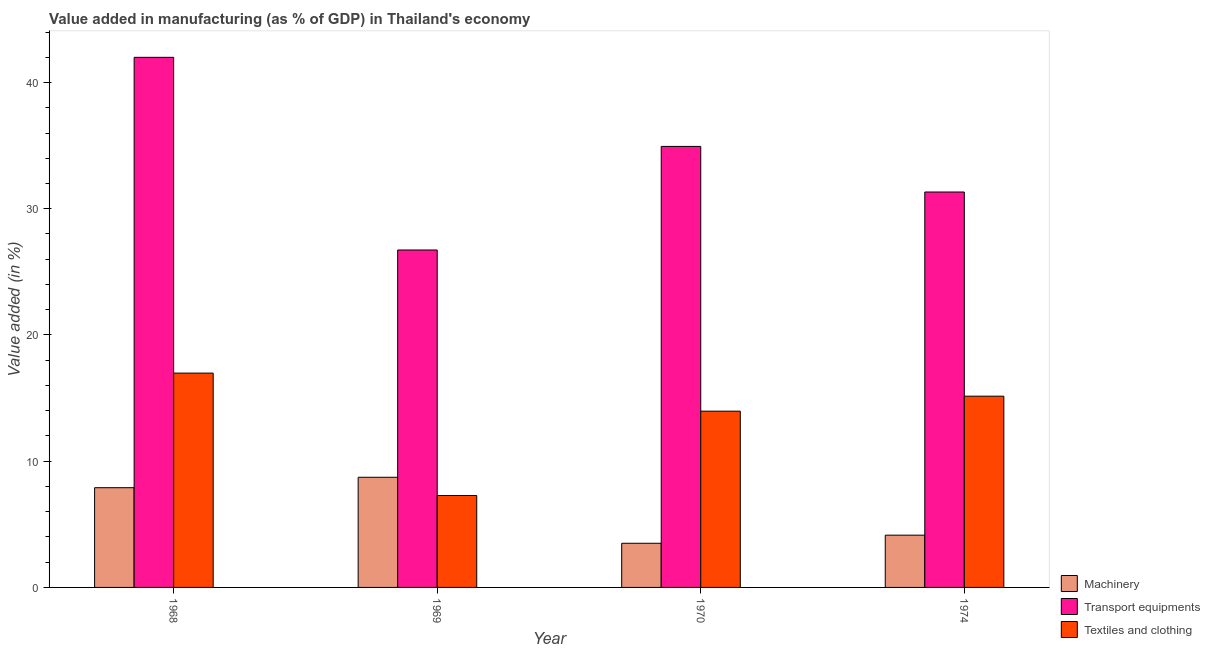How many different coloured bars are there?
Give a very brief answer. 3. Are the number of bars on each tick of the X-axis equal?
Keep it short and to the point. Yes. How many bars are there on the 3rd tick from the right?
Your answer should be compact. 3. What is the label of the 3rd group of bars from the left?
Offer a very short reply. 1970. In how many cases, is the number of bars for a given year not equal to the number of legend labels?
Make the answer very short. 0. What is the value added in manufacturing transport equipments in 1969?
Offer a terse response. 26.73. Across all years, what is the maximum value added in manufacturing transport equipments?
Your answer should be very brief. 41.99. Across all years, what is the minimum value added in manufacturing transport equipments?
Ensure brevity in your answer.  26.73. In which year was the value added in manufacturing transport equipments maximum?
Your response must be concise. 1968. In which year was the value added in manufacturing textile and clothing minimum?
Offer a terse response. 1969. What is the total value added in manufacturing textile and clothing in the graph?
Provide a succinct answer. 53.38. What is the difference between the value added in manufacturing machinery in 1969 and that in 1974?
Provide a short and direct response. 4.59. What is the difference between the value added in manufacturing machinery in 1969 and the value added in manufacturing textile and clothing in 1968?
Provide a succinct answer. 0.83. What is the average value added in manufacturing machinery per year?
Your answer should be compact. 6.07. In how many years, is the value added in manufacturing transport equipments greater than 36 %?
Offer a very short reply. 1. What is the ratio of the value added in manufacturing textile and clothing in 1968 to that in 1970?
Give a very brief answer. 1.22. Is the difference between the value added in manufacturing transport equipments in 1968 and 1970 greater than the difference between the value added in manufacturing textile and clothing in 1968 and 1970?
Keep it short and to the point. No. What is the difference between the highest and the second highest value added in manufacturing transport equipments?
Provide a succinct answer. 7.06. What is the difference between the highest and the lowest value added in manufacturing textile and clothing?
Ensure brevity in your answer.  9.7. What does the 3rd bar from the left in 1969 represents?
Provide a short and direct response. Textiles and clothing. What does the 2nd bar from the right in 1968 represents?
Your answer should be very brief. Transport equipments. Is it the case that in every year, the sum of the value added in manufacturing machinery and value added in manufacturing transport equipments is greater than the value added in manufacturing textile and clothing?
Your answer should be compact. Yes. How many bars are there?
Ensure brevity in your answer.  12. Does the graph contain grids?
Your answer should be very brief. No. Where does the legend appear in the graph?
Your answer should be very brief. Bottom right. What is the title of the graph?
Provide a short and direct response. Value added in manufacturing (as % of GDP) in Thailand's economy. What is the label or title of the Y-axis?
Provide a succinct answer. Value added (in %). What is the Value added (in %) in Machinery in 1968?
Offer a very short reply. 7.9. What is the Value added (in %) in Transport equipments in 1968?
Give a very brief answer. 41.99. What is the Value added (in %) of Textiles and clothing in 1968?
Ensure brevity in your answer.  16.98. What is the Value added (in %) in Machinery in 1969?
Offer a very short reply. 8.73. What is the Value added (in %) in Transport equipments in 1969?
Make the answer very short. 26.73. What is the Value added (in %) of Textiles and clothing in 1969?
Give a very brief answer. 7.28. What is the Value added (in %) of Machinery in 1970?
Ensure brevity in your answer.  3.5. What is the Value added (in %) in Transport equipments in 1970?
Keep it short and to the point. 34.94. What is the Value added (in %) of Textiles and clothing in 1970?
Offer a terse response. 13.96. What is the Value added (in %) of Machinery in 1974?
Offer a very short reply. 4.14. What is the Value added (in %) of Transport equipments in 1974?
Your answer should be very brief. 31.33. What is the Value added (in %) of Textiles and clothing in 1974?
Your answer should be very brief. 15.15. Across all years, what is the maximum Value added (in %) of Machinery?
Provide a short and direct response. 8.73. Across all years, what is the maximum Value added (in %) of Transport equipments?
Your answer should be compact. 41.99. Across all years, what is the maximum Value added (in %) of Textiles and clothing?
Give a very brief answer. 16.98. Across all years, what is the minimum Value added (in %) in Machinery?
Offer a terse response. 3.5. Across all years, what is the minimum Value added (in %) of Transport equipments?
Your answer should be very brief. 26.73. Across all years, what is the minimum Value added (in %) in Textiles and clothing?
Make the answer very short. 7.28. What is the total Value added (in %) in Machinery in the graph?
Give a very brief answer. 24.27. What is the total Value added (in %) of Transport equipments in the graph?
Make the answer very short. 134.99. What is the total Value added (in %) of Textiles and clothing in the graph?
Your answer should be compact. 53.38. What is the difference between the Value added (in %) in Machinery in 1968 and that in 1969?
Offer a very short reply. -0.83. What is the difference between the Value added (in %) in Transport equipments in 1968 and that in 1969?
Give a very brief answer. 15.26. What is the difference between the Value added (in %) of Textiles and clothing in 1968 and that in 1969?
Provide a succinct answer. 9.7. What is the difference between the Value added (in %) in Machinery in 1968 and that in 1970?
Your answer should be very brief. 4.4. What is the difference between the Value added (in %) of Transport equipments in 1968 and that in 1970?
Keep it short and to the point. 7.06. What is the difference between the Value added (in %) of Textiles and clothing in 1968 and that in 1970?
Ensure brevity in your answer.  3.02. What is the difference between the Value added (in %) in Machinery in 1968 and that in 1974?
Offer a terse response. 3.76. What is the difference between the Value added (in %) of Transport equipments in 1968 and that in 1974?
Offer a very short reply. 10.67. What is the difference between the Value added (in %) in Textiles and clothing in 1968 and that in 1974?
Provide a short and direct response. 1.83. What is the difference between the Value added (in %) of Machinery in 1969 and that in 1970?
Ensure brevity in your answer.  5.23. What is the difference between the Value added (in %) of Transport equipments in 1969 and that in 1970?
Your answer should be compact. -8.21. What is the difference between the Value added (in %) in Textiles and clothing in 1969 and that in 1970?
Offer a terse response. -6.68. What is the difference between the Value added (in %) of Machinery in 1969 and that in 1974?
Your answer should be compact. 4.59. What is the difference between the Value added (in %) of Transport equipments in 1969 and that in 1974?
Your answer should be compact. -4.59. What is the difference between the Value added (in %) of Textiles and clothing in 1969 and that in 1974?
Give a very brief answer. -7.87. What is the difference between the Value added (in %) of Machinery in 1970 and that in 1974?
Ensure brevity in your answer.  -0.64. What is the difference between the Value added (in %) in Transport equipments in 1970 and that in 1974?
Provide a succinct answer. 3.61. What is the difference between the Value added (in %) of Textiles and clothing in 1970 and that in 1974?
Give a very brief answer. -1.19. What is the difference between the Value added (in %) in Machinery in 1968 and the Value added (in %) in Transport equipments in 1969?
Give a very brief answer. -18.83. What is the difference between the Value added (in %) of Machinery in 1968 and the Value added (in %) of Textiles and clothing in 1969?
Make the answer very short. 0.62. What is the difference between the Value added (in %) in Transport equipments in 1968 and the Value added (in %) in Textiles and clothing in 1969?
Ensure brevity in your answer.  34.71. What is the difference between the Value added (in %) of Machinery in 1968 and the Value added (in %) of Transport equipments in 1970?
Offer a very short reply. -27.04. What is the difference between the Value added (in %) in Machinery in 1968 and the Value added (in %) in Textiles and clothing in 1970?
Offer a very short reply. -6.06. What is the difference between the Value added (in %) of Transport equipments in 1968 and the Value added (in %) of Textiles and clothing in 1970?
Your response must be concise. 28.03. What is the difference between the Value added (in %) in Machinery in 1968 and the Value added (in %) in Transport equipments in 1974?
Provide a short and direct response. -23.43. What is the difference between the Value added (in %) of Machinery in 1968 and the Value added (in %) of Textiles and clothing in 1974?
Make the answer very short. -7.25. What is the difference between the Value added (in %) of Transport equipments in 1968 and the Value added (in %) of Textiles and clothing in 1974?
Your answer should be very brief. 26.84. What is the difference between the Value added (in %) of Machinery in 1969 and the Value added (in %) of Transport equipments in 1970?
Your answer should be compact. -26.21. What is the difference between the Value added (in %) of Machinery in 1969 and the Value added (in %) of Textiles and clothing in 1970?
Make the answer very short. -5.24. What is the difference between the Value added (in %) of Transport equipments in 1969 and the Value added (in %) of Textiles and clothing in 1970?
Your answer should be very brief. 12.77. What is the difference between the Value added (in %) in Machinery in 1969 and the Value added (in %) in Transport equipments in 1974?
Give a very brief answer. -22.6. What is the difference between the Value added (in %) in Machinery in 1969 and the Value added (in %) in Textiles and clothing in 1974?
Provide a short and direct response. -6.42. What is the difference between the Value added (in %) in Transport equipments in 1969 and the Value added (in %) in Textiles and clothing in 1974?
Offer a very short reply. 11.58. What is the difference between the Value added (in %) of Machinery in 1970 and the Value added (in %) of Transport equipments in 1974?
Keep it short and to the point. -27.83. What is the difference between the Value added (in %) in Machinery in 1970 and the Value added (in %) in Textiles and clothing in 1974?
Ensure brevity in your answer.  -11.65. What is the difference between the Value added (in %) in Transport equipments in 1970 and the Value added (in %) in Textiles and clothing in 1974?
Make the answer very short. 19.79. What is the average Value added (in %) in Machinery per year?
Provide a short and direct response. 6.07. What is the average Value added (in %) of Transport equipments per year?
Provide a succinct answer. 33.75. What is the average Value added (in %) in Textiles and clothing per year?
Provide a short and direct response. 13.34. In the year 1968, what is the difference between the Value added (in %) of Machinery and Value added (in %) of Transport equipments?
Provide a succinct answer. -34.09. In the year 1968, what is the difference between the Value added (in %) of Machinery and Value added (in %) of Textiles and clothing?
Make the answer very short. -9.08. In the year 1968, what is the difference between the Value added (in %) in Transport equipments and Value added (in %) in Textiles and clothing?
Your answer should be very brief. 25.02. In the year 1969, what is the difference between the Value added (in %) of Machinery and Value added (in %) of Transport equipments?
Keep it short and to the point. -18.01. In the year 1969, what is the difference between the Value added (in %) of Machinery and Value added (in %) of Textiles and clothing?
Ensure brevity in your answer.  1.44. In the year 1969, what is the difference between the Value added (in %) in Transport equipments and Value added (in %) in Textiles and clothing?
Your answer should be very brief. 19.45. In the year 1970, what is the difference between the Value added (in %) in Machinery and Value added (in %) in Transport equipments?
Make the answer very short. -31.44. In the year 1970, what is the difference between the Value added (in %) in Machinery and Value added (in %) in Textiles and clothing?
Ensure brevity in your answer.  -10.47. In the year 1970, what is the difference between the Value added (in %) in Transport equipments and Value added (in %) in Textiles and clothing?
Keep it short and to the point. 20.97. In the year 1974, what is the difference between the Value added (in %) of Machinery and Value added (in %) of Transport equipments?
Provide a short and direct response. -27.19. In the year 1974, what is the difference between the Value added (in %) in Machinery and Value added (in %) in Textiles and clothing?
Keep it short and to the point. -11.01. In the year 1974, what is the difference between the Value added (in %) of Transport equipments and Value added (in %) of Textiles and clothing?
Your answer should be compact. 16.17. What is the ratio of the Value added (in %) in Machinery in 1968 to that in 1969?
Keep it short and to the point. 0.91. What is the ratio of the Value added (in %) in Transport equipments in 1968 to that in 1969?
Offer a very short reply. 1.57. What is the ratio of the Value added (in %) of Textiles and clothing in 1968 to that in 1969?
Keep it short and to the point. 2.33. What is the ratio of the Value added (in %) in Machinery in 1968 to that in 1970?
Offer a very short reply. 2.26. What is the ratio of the Value added (in %) of Transport equipments in 1968 to that in 1970?
Your response must be concise. 1.2. What is the ratio of the Value added (in %) of Textiles and clothing in 1968 to that in 1970?
Keep it short and to the point. 1.22. What is the ratio of the Value added (in %) in Machinery in 1968 to that in 1974?
Offer a terse response. 1.91. What is the ratio of the Value added (in %) of Transport equipments in 1968 to that in 1974?
Your response must be concise. 1.34. What is the ratio of the Value added (in %) in Textiles and clothing in 1968 to that in 1974?
Give a very brief answer. 1.12. What is the ratio of the Value added (in %) in Machinery in 1969 to that in 1970?
Give a very brief answer. 2.49. What is the ratio of the Value added (in %) of Transport equipments in 1969 to that in 1970?
Provide a short and direct response. 0.77. What is the ratio of the Value added (in %) in Textiles and clothing in 1969 to that in 1970?
Provide a succinct answer. 0.52. What is the ratio of the Value added (in %) in Machinery in 1969 to that in 1974?
Provide a succinct answer. 2.11. What is the ratio of the Value added (in %) of Transport equipments in 1969 to that in 1974?
Provide a short and direct response. 0.85. What is the ratio of the Value added (in %) of Textiles and clothing in 1969 to that in 1974?
Ensure brevity in your answer.  0.48. What is the ratio of the Value added (in %) of Machinery in 1970 to that in 1974?
Provide a short and direct response. 0.84. What is the ratio of the Value added (in %) of Transport equipments in 1970 to that in 1974?
Your answer should be very brief. 1.12. What is the ratio of the Value added (in %) in Textiles and clothing in 1970 to that in 1974?
Make the answer very short. 0.92. What is the difference between the highest and the second highest Value added (in %) of Machinery?
Your answer should be compact. 0.83. What is the difference between the highest and the second highest Value added (in %) of Transport equipments?
Offer a terse response. 7.06. What is the difference between the highest and the second highest Value added (in %) in Textiles and clothing?
Offer a very short reply. 1.83. What is the difference between the highest and the lowest Value added (in %) of Machinery?
Your answer should be compact. 5.23. What is the difference between the highest and the lowest Value added (in %) in Transport equipments?
Ensure brevity in your answer.  15.26. What is the difference between the highest and the lowest Value added (in %) of Textiles and clothing?
Give a very brief answer. 9.7. 